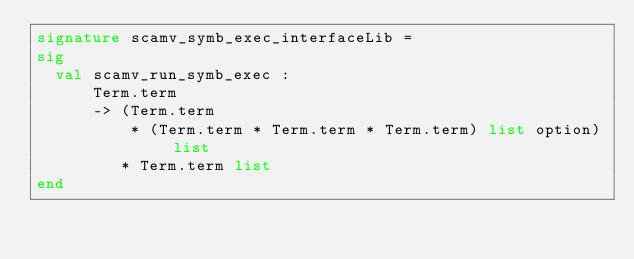Convert code to text. <code><loc_0><loc_0><loc_500><loc_500><_SML_>signature scamv_symb_exec_interfaceLib =
sig
  val scamv_run_symb_exec :
      Term.term
      -> (Term.term
          * (Term.term * Term.term * Term.term) list option) list
         * Term.term list
end
</code> 